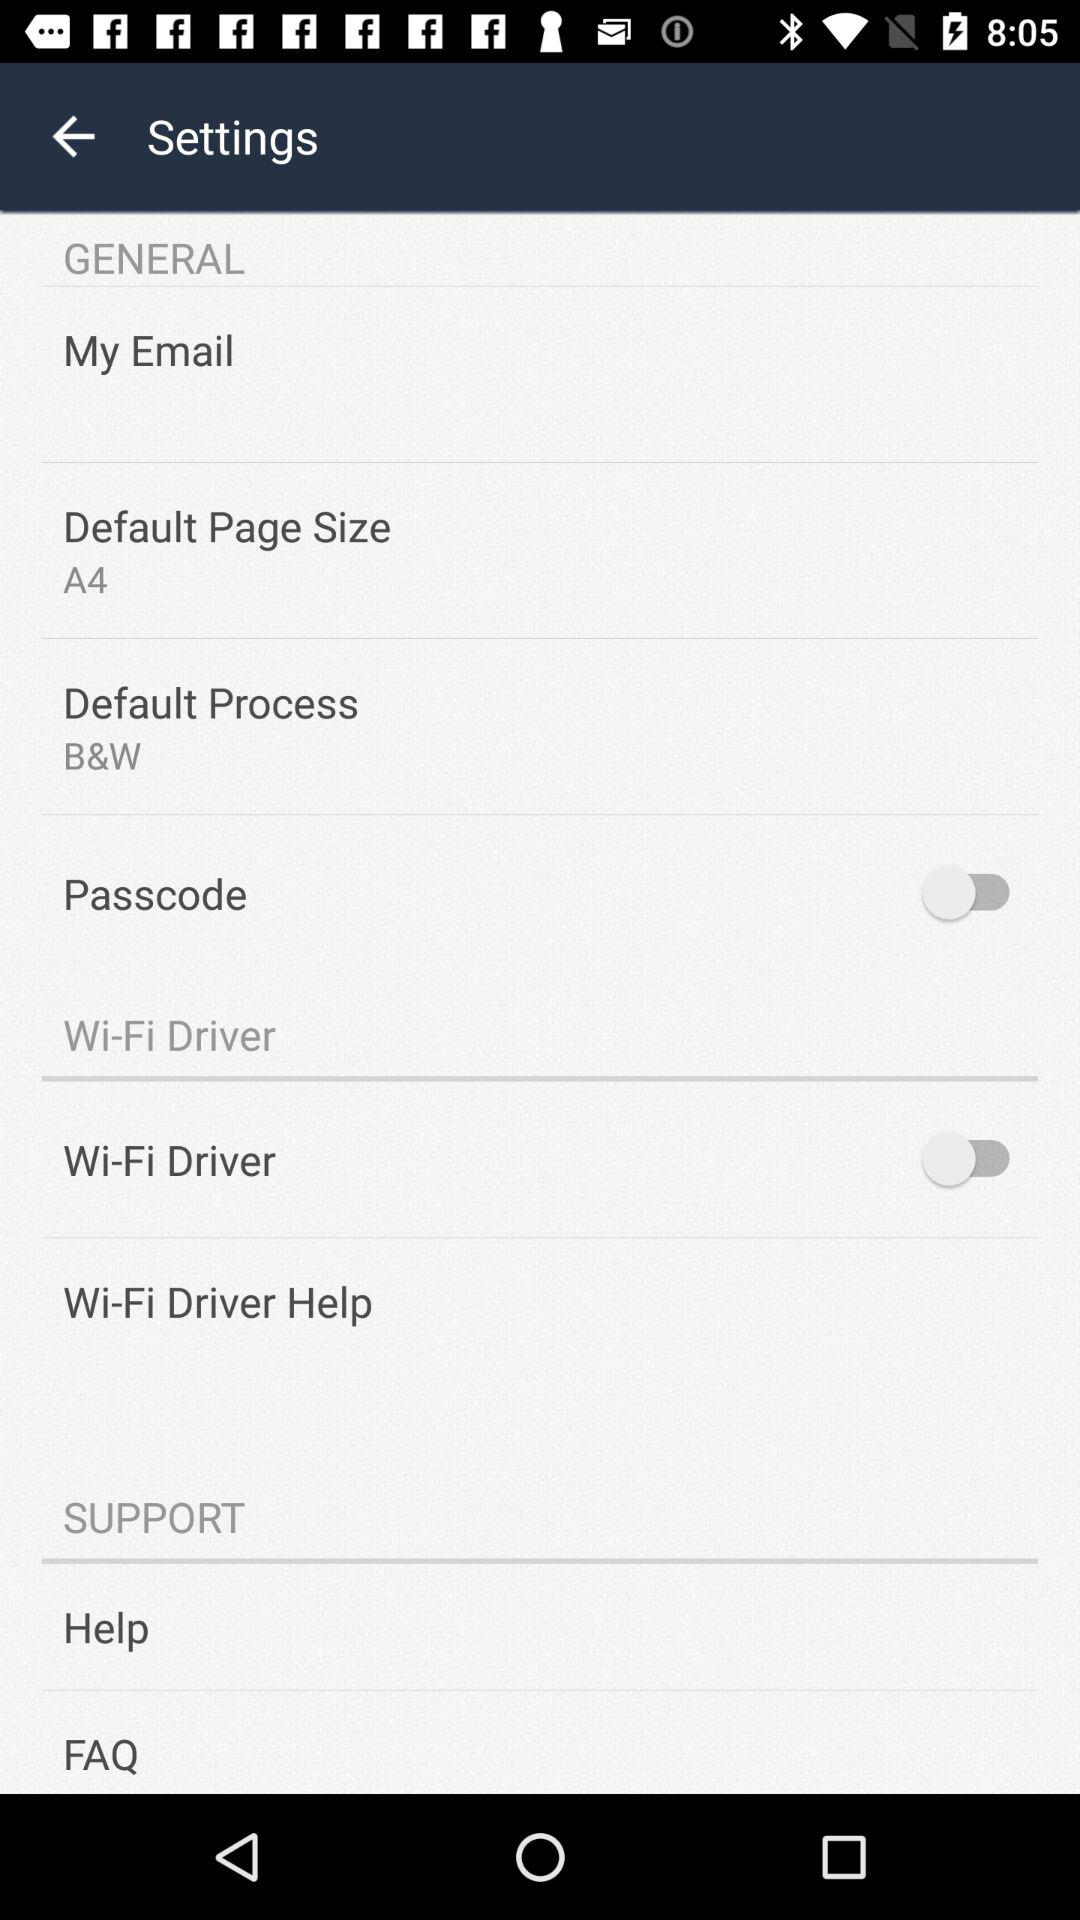What is the status of "Passcode"? The status is "off". 